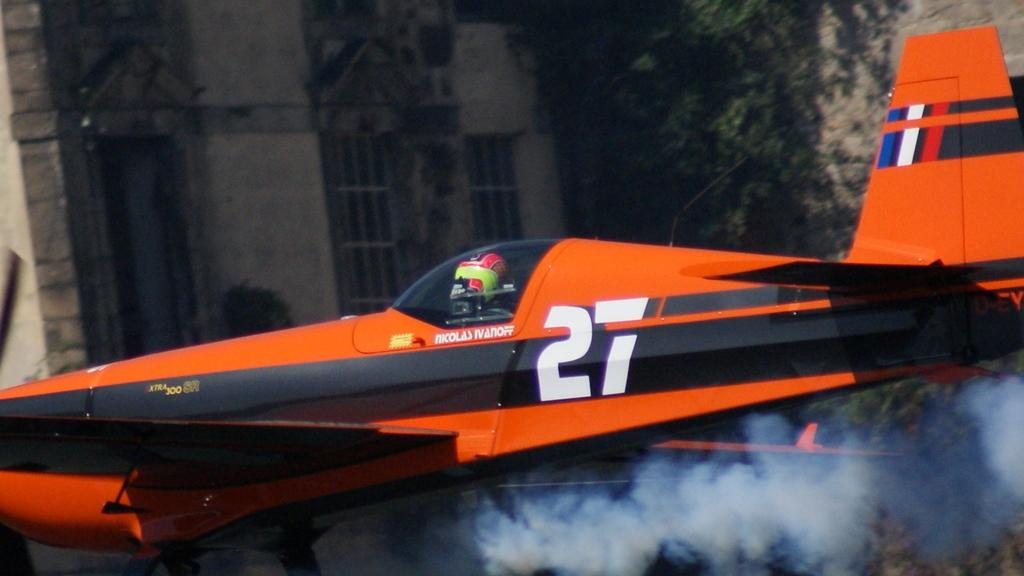Provide a one-sentence caption for the provided image. Nicolas Ivanoff flies his red number 27 plane. 